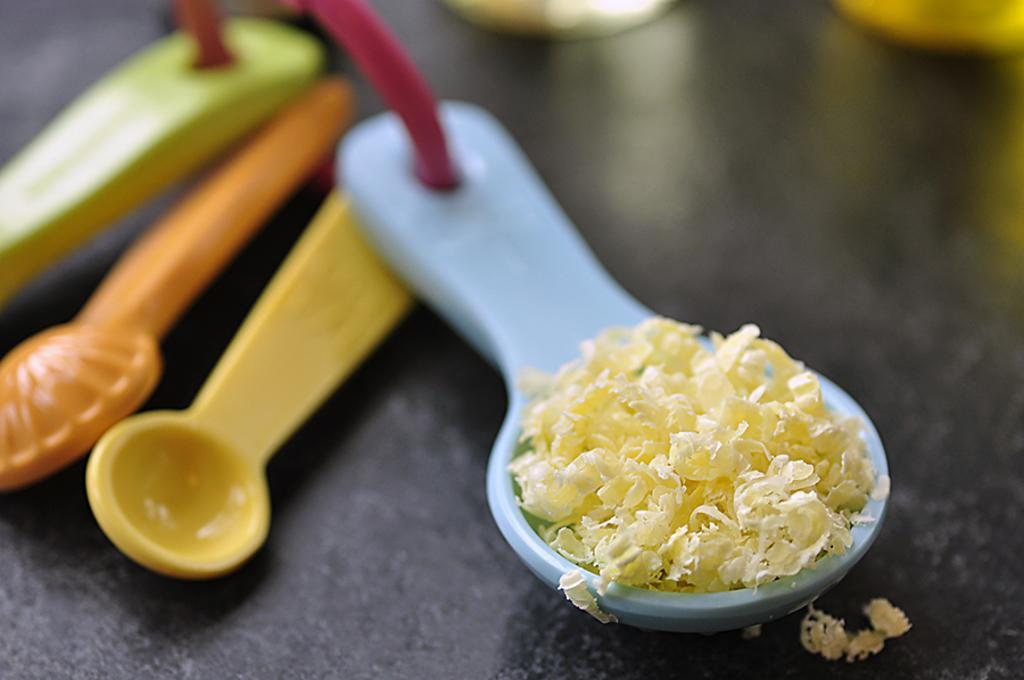How would you summarize this image in a sentence or two? There is some food in the spoon. And there are some different colors of spoons here on the floor. 